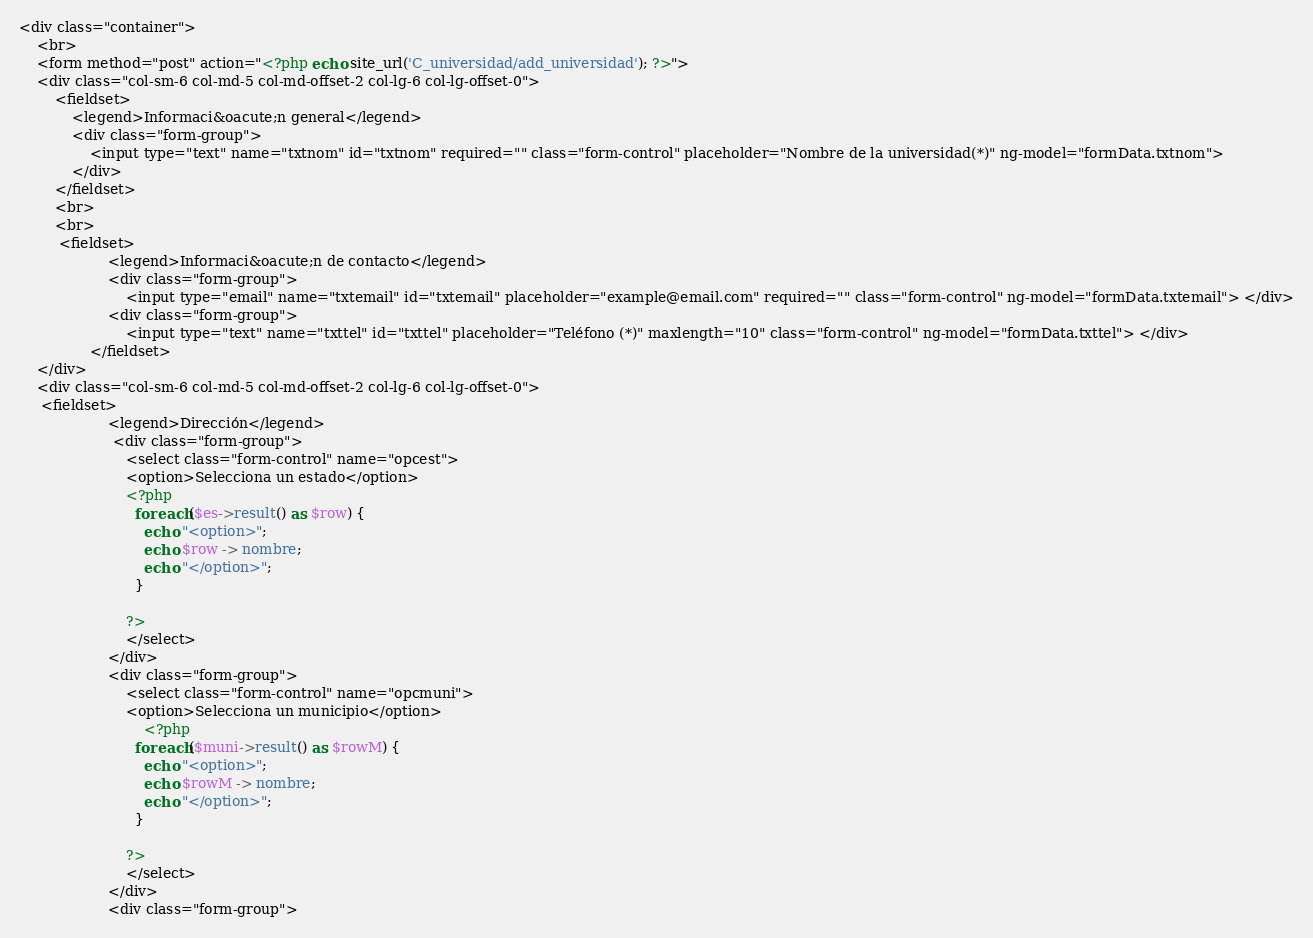Convert code to text. <code><loc_0><loc_0><loc_500><loc_500><_PHP_><div class="container">
	<br>
	<form method="post" action="<?php echo site_url('C_universidad/add_universidad'); ?>">
    <div class="col-sm-6 col-md-5 col-md-offset-2 col-lg-6 col-lg-offset-0">
        <fieldset>
            <legend>Informaci&oacute;n general</legend>
            <div class="form-group">
                <input type="text" name="txtnom" id="txtnom" required="" class="form-control" placeholder="Nombre de la universidad(*)" ng-model="formData.txtnom"> 
            </div>          
        </fieldset>
        <br>
        <br>
         <fieldset>
                    <legend>Informaci&oacute;n de contacto</legend>
                    <div class="form-group">
                        <input type="email" name="txtemail" id="txtemail" placeholder="example@email.com" required="" class="form-control" ng-model="formData.txtemail"> </div>
                    <div class="form-group">
                        <input type="text" name="txttel" id="txttel" placeholder="Teléfono (*)" maxlength="10" class="form-control" ng-model="formData.txttel"> </div>
                </fieldset>
    </div>
    <div class="col-sm-6 col-md-5 col-md-offset-2 col-lg-6 col-lg-offset-0">
     <fieldset>
                    <legend>Dirección</legend>
                     <div class="form-group">
                        <select class="form-control" name="opcest"> 
                        <option>Selecciona un estado</option>
                        <?php 
                          foreach($es->result() as $row) {
                            echo "<option>";
                            echo $row -> nombre;
                            echo "</option>";
                          }
                            
                        ?>
                        </select>
                    </div>
                    <div class="form-group">
                        <select class="form-control" name="opcmuni"> 
                        <option>Selecciona un municipio</option>
                            <?php 
                          foreach($muni->result() as $rowM) {
                            echo "<option>";
                            echo $rowM -> nombre;
                            echo "</option>";
                          }
                            
                        ?>
                        </select>
                    </div>
                    <div class="form-group"></code> 